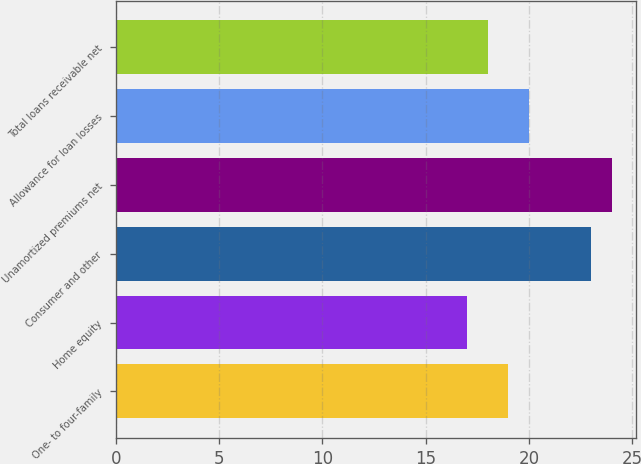<chart> <loc_0><loc_0><loc_500><loc_500><bar_chart><fcel>One- to four-family<fcel>Home equity<fcel>Consumer and other<fcel>Unamortized premiums net<fcel>Allowance for loan losses<fcel>Total loans receivable net<nl><fcel>19<fcel>17<fcel>23<fcel>24<fcel>20<fcel>18<nl></chart> 